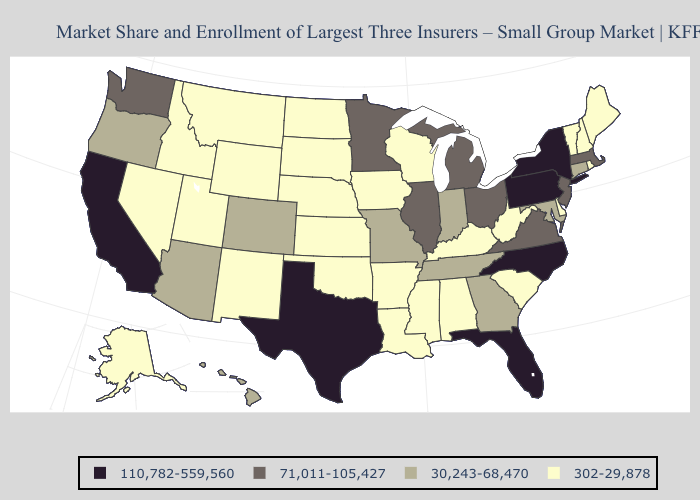Does Hawaii have the lowest value in the West?
Write a very short answer. No. Does Alaska have a lower value than Iowa?
Answer briefly. No. Among the states that border Idaho , does Wyoming have the highest value?
Quick response, please. No. Does New Jersey have the same value as Nevada?
Short answer required. No. Does the first symbol in the legend represent the smallest category?
Give a very brief answer. No. Name the states that have a value in the range 110,782-559,560?
Quick response, please. California, Florida, New York, North Carolina, Pennsylvania, Texas. What is the lowest value in states that border Georgia?
Quick response, please. 302-29,878. Does Tennessee have the highest value in the South?
Write a very short answer. No. What is the highest value in states that border Ohio?
Be succinct. 110,782-559,560. What is the highest value in states that border Idaho?
Write a very short answer. 71,011-105,427. What is the value of Montana?
Write a very short answer. 302-29,878. Does Nebraska have the lowest value in the USA?
Concise answer only. Yes. What is the highest value in states that border Minnesota?
Keep it brief. 302-29,878. What is the lowest value in the Northeast?
Give a very brief answer. 302-29,878. 